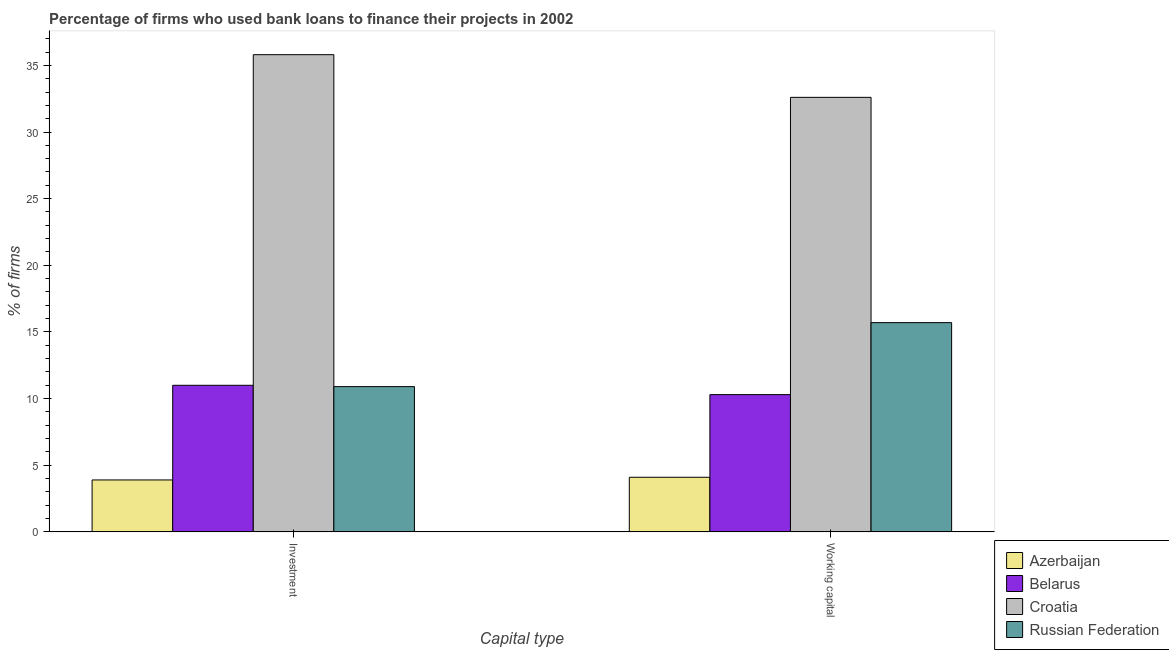How many different coloured bars are there?
Your answer should be compact. 4. How many bars are there on the 2nd tick from the left?
Provide a succinct answer. 4. How many bars are there on the 1st tick from the right?
Keep it short and to the point. 4. What is the label of the 1st group of bars from the left?
Provide a succinct answer. Investment. Across all countries, what is the maximum percentage of firms using banks to finance working capital?
Provide a short and direct response. 32.6. Across all countries, what is the minimum percentage of firms using banks to finance investment?
Provide a succinct answer. 3.9. In which country was the percentage of firms using banks to finance working capital maximum?
Offer a terse response. Croatia. In which country was the percentage of firms using banks to finance investment minimum?
Your answer should be very brief. Azerbaijan. What is the total percentage of firms using banks to finance working capital in the graph?
Give a very brief answer. 62.7. What is the difference between the percentage of firms using banks to finance working capital in Croatia and that in Russian Federation?
Provide a short and direct response. 16.9. What is the difference between the percentage of firms using banks to finance working capital in Russian Federation and the percentage of firms using banks to finance investment in Belarus?
Your response must be concise. 4.7. What is the average percentage of firms using banks to finance working capital per country?
Your answer should be compact. 15.68. What is the difference between the percentage of firms using banks to finance investment and percentage of firms using banks to finance working capital in Belarus?
Provide a short and direct response. 0.7. What is the ratio of the percentage of firms using banks to finance working capital in Azerbaijan to that in Croatia?
Your response must be concise. 0.13. Is the percentage of firms using banks to finance investment in Azerbaijan less than that in Russian Federation?
Offer a very short reply. Yes. What does the 2nd bar from the left in Investment represents?
Keep it short and to the point. Belarus. What does the 3rd bar from the right in Investment represents?
Make the answer very short. Belarus. How many countries are there in the graph?
Your answer should be very brief. 4. What is the difference between two consecutive major ticks on the Y-axis?
Provide a short and direct response. 5. Are the values on the major ticks of Y-axis written in scientific E-notation?
Keep it short and to the point. No. Does the graph contain any zero values?
Make the answer very short. No. How many legend labels are there?
Your response must be concise. 4. What is the title of the graph?
Your response must be concise. Percentage of firms who used bank loans to finance their projects in 2002. What is the label or title of the X-axis?
Provide a short and direct response. Capital type. What is the label or title of the Y-axis?
Your answer should be compact. % of firms. What is the % of firms in Azerbaijan in Investment?
Your response must be concise. 3.9. What is the % of firms of Croatia in Investment?
Your response must be concise. 35.8. What is the % of firms in Russian Federation in Investment?
Make the answer very short. 10.9. What is the % of firms in Croatia in Working capital?
Ensure brevity in your answer.  32.6. What is the % of firms in Russian Federation in Working capital?
Keep it short and to the point. 15.7. Across all Capital type, what is the maximum % of firms in Belarus?
Provide a succinct answer. 11. Across all Capital type, what is the maximum % of firms of Croatia?
Offer a terse response. 35.8. Across all Capital type, what is the minimum % of firms of Croatia?
Your answer should be compact. 32.6. What is the total % of firms in Belarus in the graph?
Provide a succinct answer. 21.3. What is the total % of firms in Croatia in the graph?
Your answer should be very brief. 68.4. What is the total % of firms of Russian Federation in the graph?
Your answer should be compact. 26.6. What is the difference between the % of firms in Azerbaijan in Investment and that in Working capital?
Offer a terse response. -0.2. What is the difference between the % of firms of Belarus in Investment and that in Working capital?
Offer a terse response. 0.7. What is the difference between the % of firms of Azerbaijan in Investment and the % of firms of Belarus in Working capital?
Your response must be concise. -6.4. What is the difference between the % of firms in Azerbaijan in Investment and the % of firms in Croatia in Working capital?
Provide a short and direct response. -28.7. What is the difference between the % of firms of Belarus in Investment and the % of firms of Croatia in Working capital?
Ensure brevity in your answer.  -21.6. What is the difference between the % of firms in Belarus in Investment and the % of firms in Russian Federation in Working capital?
Ensure brevity in your answer.  -4.7. What is the difference between the % of firms of Croatia in Investment and the % of firms of Russian Federation in Working capital?
Keep it short and to the point. 20.1. What is the average % of firms in Belarus per Capital type?
Your response must be concise. 10.65. What is the average % of firms in Croatia per Capital type?
Your answer should be compact. 34.2. What is the difference between the % of firms of Azerbaijan and % of firms of Belarus in Investment?
Your answer should be compact. -7.1. What is the difference between the % of firms of Azerbaijan and % of firms of Croatia in Investment?
Ensure brevity in your answer.  -31.9. What is the difference between the % of firms of Azerbaijan and % of firms of Russian Federation in Investment?
Provide a succinct answer. -7. What is the difference between the % of firms in Belarus and % of firms in Croatia in Investment?
Offer a very short reply. -24.8. What is the difference between the % of firms in Croatia and % of firms in Russian Federation in Investment?
Offer a terse response. 24.9. What is the difference between the % of firms of Azerbaijan and % of firms of Croatia in Working capital?
Keep it short and to the point. -28.5. What is the difference between the % of firms of Azerbaijan and % of firms of Russian Federation in Working capital?
Offer a very short reply. -11.6. What is the difference between the % of firms in Belarus and % of firms in Croatia in Working capital?
Provide a short and direct response. -22.3. What is the difference between the % of firms in Belarus and % of firms in Russian Federation in Working capital?
Keep it short and to the point. -5.4. What is the ratio of the % of firms in Azerbaijan in Investment to that in Working capital?
Make the answer very short. 0.95. What is the ratio of the % of firms of Belarus in Investment to that in Working capital?
Your answer should be very brief. 1.07. What is the ratio of the % of firms in Croatia in Investment to that in Working capital?
Make the answer very short. 1.1. What is the ratio of the % of firms in Russian Federation in Investment to that in Working capital?
Offer a terse response. 0.69. What is the difference between the highest and the second highest % of firms in Russian Federation?
Provide a short and direct response. 4.8. What is the difference between the highest and the lowest % of firms of Azerbaijan?
Your answer should be very brief. 0.2. What is the difference between the highest and the lowest % of firms in Belarus?
Your answer should be very brief. 0.7. What is the difference between the highest and the lowest % of firms in Croatia?
Provide a succinct answer. 3.2. 